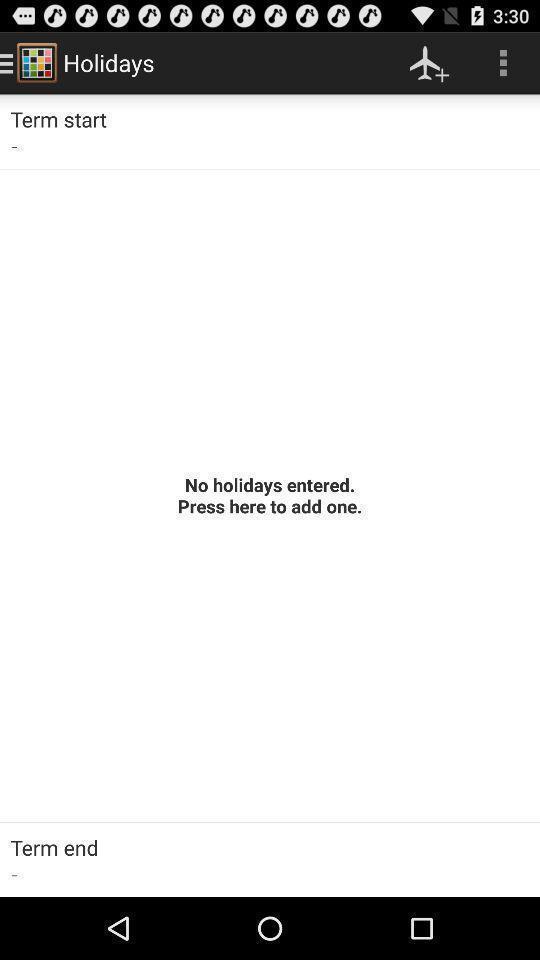Give me a summary of this screen capture. Screen showing no holidays entered. 